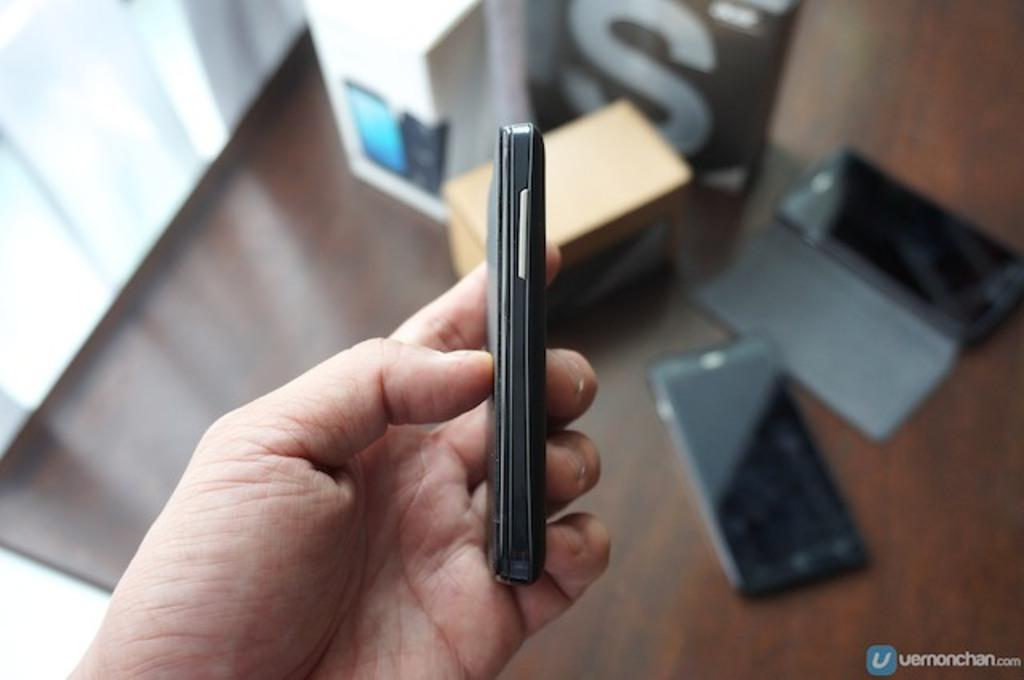What is the person holding in the image? There is a person's hand holding a cellphone in the image. What else can be seen on the backside in the image? There are cellphones and boxes visible on the backside in the image. What type of furniture is present in the image? There is a table in the image. What type of engine can be seen in the image? There is no engine present in the image. Can you describe the picture hanging on the wall in the image? There is no picture hanging on the wall mentioned in the provided facts, so we cannot describe it. 